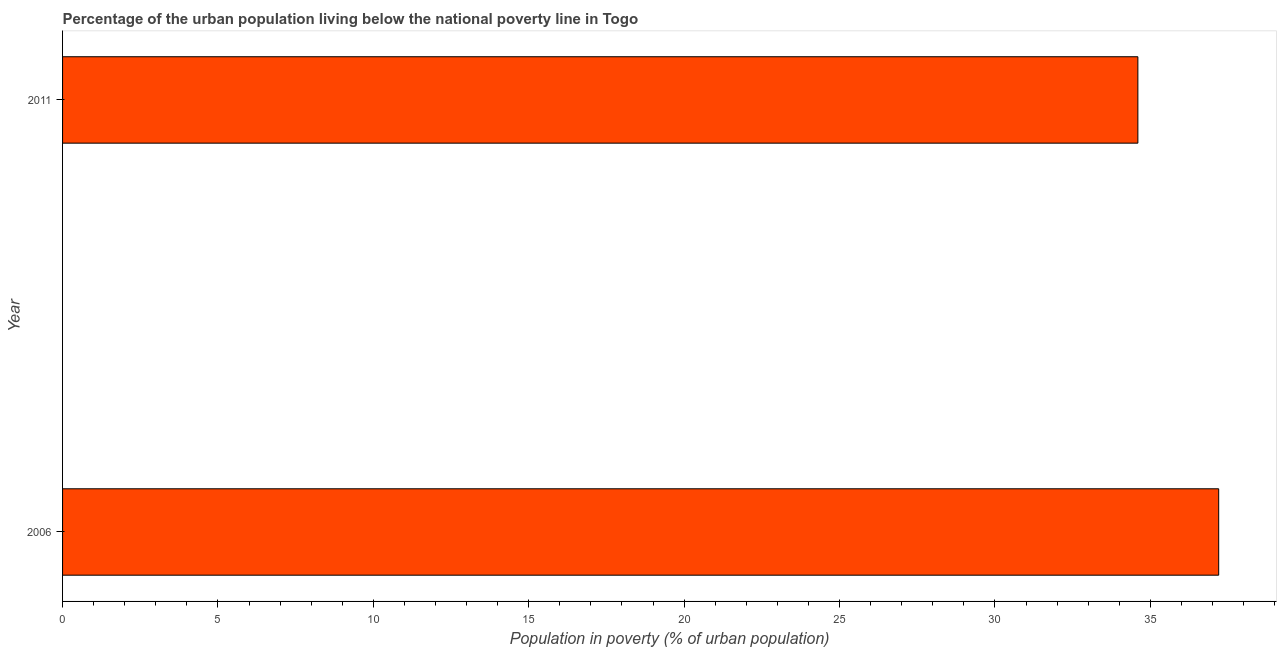Does the graph contain any zero values?
Your answer should be compact. No. What is the title of the graph?
Offer a very short reply. Percentage of the urban population living below the national poverty line in Togo. What is the label or title of the X-axis?
Provide a succinct answer. Population in poverty (% of urban population). What is the label or title of the Y-axis?
Your answer should be compact. Year. What is the percentage of urban population living below poverty line in 2011?
Give a very brief answer. 34.6. Across all years, what is the maximum percentage of urban population living below poverty line?
Give a very brief answer. 37.2. Across all years, what is the minimum percentage of urban population living below poverty line?
Offer a terse response. 34.6. In which year was the percentage of urban population living below poverty line minimum?
Ensure brevity in your answer.  2011. What is the sum of the percentage of urban population living below poverty line?
Make the answer very short. 71.8. What is the difference between the percentage of urban population living below poverty line in 2006 and 2011?
Your response must be concise. 2.6. What is the average percentage of urban population living below poverty line per year?
Your answer should be very brief. 35.9. What is the median percentage of urban population living below poverty line?
Your response must be concise. 35.9. In how many years, is the percentage of urban population living below poverty line greater than 24 %?
Make the answer very short. 2. What is the ratio of the percentage of urban population living below poverty line in 2006 to that in 2011?
Your answer should be compact. 1.07. How many bars are there?
Make the answer very short. 2. What is the difference between two consecutive major ticks on the X-axis?
Ensure brevity in your answer.  5. What is the Population in poverty (% of urban population) in 2006?
Offer a very short reply. 37.2. What is the Population in poverty (% of urban population) in 2011?
Ensure brevity in your answer.  34.6. What is the difference between the Population in poverty (% of urban population) in 2006 and 2011?
Provide a short and direct response. 2.6. What is the ratio of the Population in poverty (% of urban population) in 2006 to that in 2011?
Your response must be concise. 1.07. 